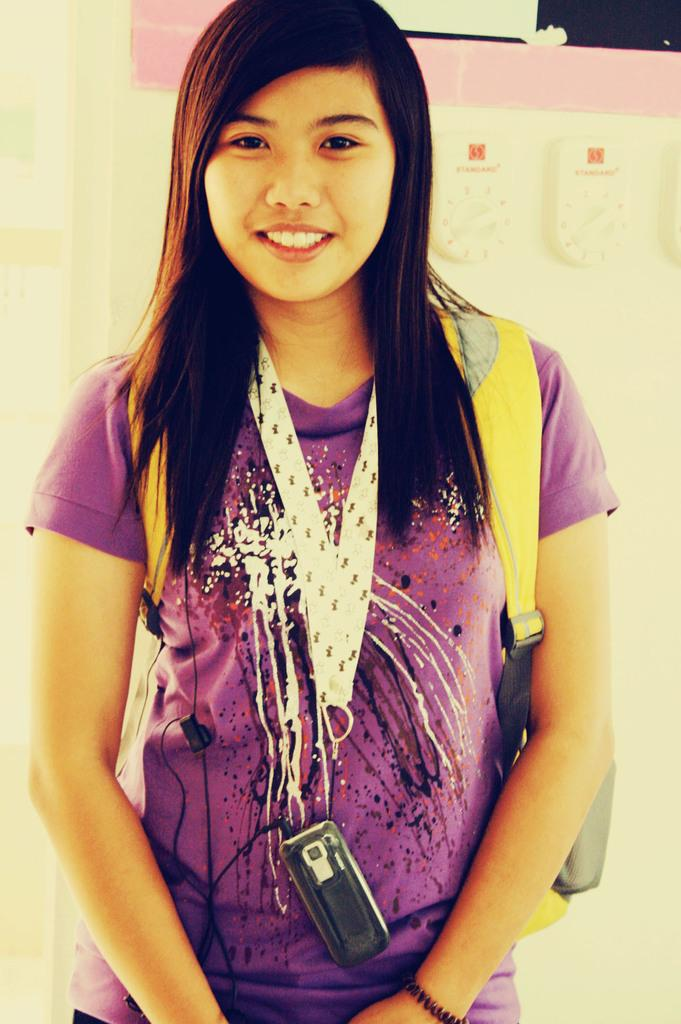Who is present in the image? There is a woman in the image. What is the woman doing in the image? The woman is standing and smiling. What is the woman wearing around her neck? There is a mobile hanging around her neck. What can be seen in the background of the image? There are objects visible in the background of the image. What type of wool is being folded in the image? There is no wool or folding activity present in the image. 